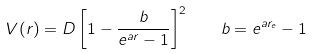<formula> <loc_0><loc_0><loc_500><loc_500>V ( r ) = D \left [ 1 - \frac { b } { e ^ { a r } - 1 } \right ] ^ { 2 } \quad b = e ^ { a r _ { e } } - 1</formula> 